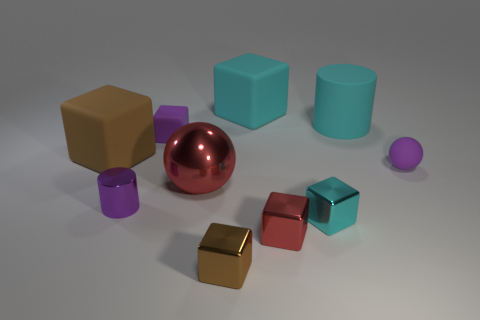Subtract 1 blocks. How many blocks are left? 5 Subtract all brown blocks. How many blocks are left? 4 Subtract all red metal blocks. How many blocks are left? 5 Subtract all blue blocks. Subtract all brown balls. How many blocks are left? 6 Subtract all spheres. How many objects are left? 8 Subtract all big metal objects. Subtract all green shiny balls. How many objects are left? 9 Add 1 red shiny cubes. How many red shiny cubes are left? 2 Add 2 small purple shiny cubes. How many small purple shiny cubes exist? 2 Subtract 0 brown balls. How many objects are left? 10 